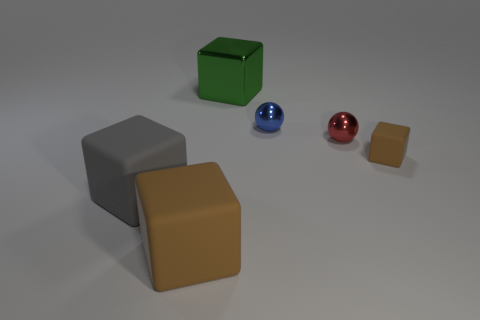There is a brown thing that is the same size as the blue sphere; what shape is it?
Your response must be concise. Cube. There is a block that is on the right side of the green shiny cube left of the blue object; are there any tiny rubber blocks that are behind it?
Make the answer very short. No. What number of small red metal things are there?
Give a very brief answer. 1. How many things are brown matte things left of the small red metallic object or matte things that are to the right of the blue metal sphere?
Offer a terse response. 2. Does the brown cube right of the green block have the same size as the red ball?
Provide a short and direct response. Yes. The other metallic object that is the same shape as the gray thing is what size?
Your answer should be compact. Large. What is the material of the gray thing that is the same size as the green metallic thing?
Your answer should be compact. Rubber. What material is the gray thing that is the same shape as the big green thing?
Ensure brevity in your answer.  Rubber. What number of other things are there of the same size as the red metal object?
Make the answer very short. 2. What size is the other block that is the same color as the tiny matte cube?
Make the answer very short. Large. 